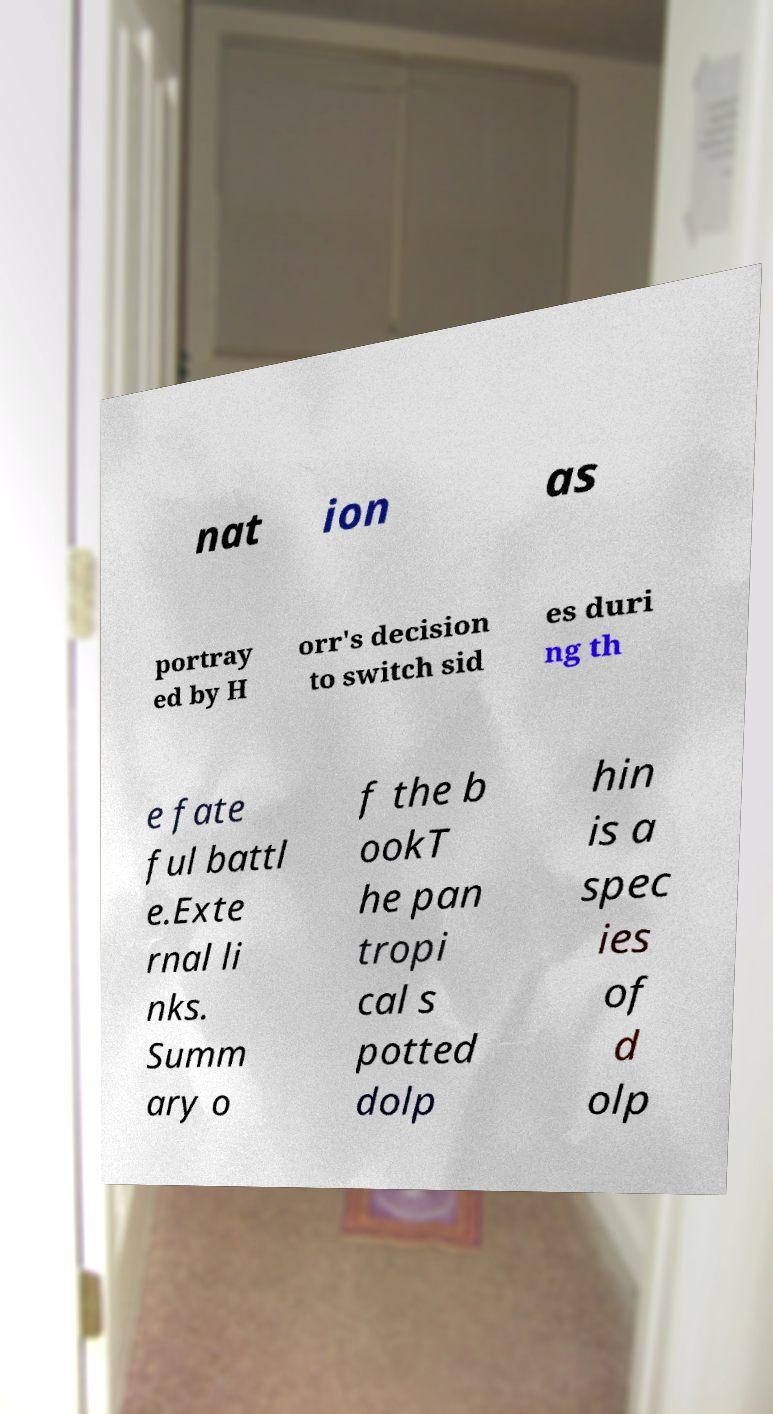I need the written content from this picture converted into text. Can you do that? nat ion as portray ed by H orr's decision to switch sid es duri ng th e fate ful battl e.Exte rnal li nks. Summ ary o f the b ookT he pan tropi cal s potted dolp hin is a spec ies of d olp 